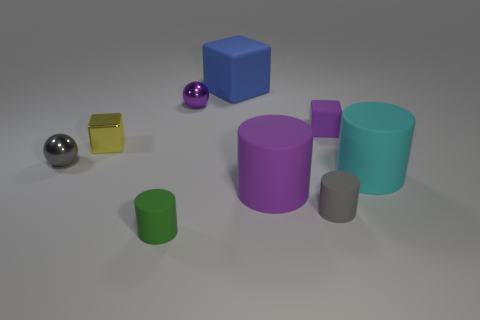Is the metallic block the same color as the small rubber cube?
Make the answer very short. No. How many objects are purple things that are in front of the metallic block or gray shiny objects?
Offer a terse response. 2. What shape is the purple shiny thing that is the same size as the yellow object?
Keep it short and to the point. Sphere. There is a sphere right of the tiny gray ball; is its size the same as the ball that is on the left side of the small purple metallic sphere?
Your answer should be very brief. Yes. What is the color of the tiny cube that is the same material as the cyan cylinder?
Provide a succinct answer. Purple. Are the tiny block that is to the left of the purple cylinder and the tiny gray thing on the right side of the big matte block made of the same material?
Provide a short and direct response. No. Is there a purple cylinder that has the same size as the purple block?
Offer a terse response. No. There is a cylinder that is to the left of the small object behind the small purple block; how big is it?
Your answer should be compact. Small. How many other blocks have the same color as the shiny cube?
Make the answer very short. 0. The cyan thing that is to the right of the tiny yellow object that is right of the tiny gray ball is what shape?
Offer a very short reply. Cylinder. 